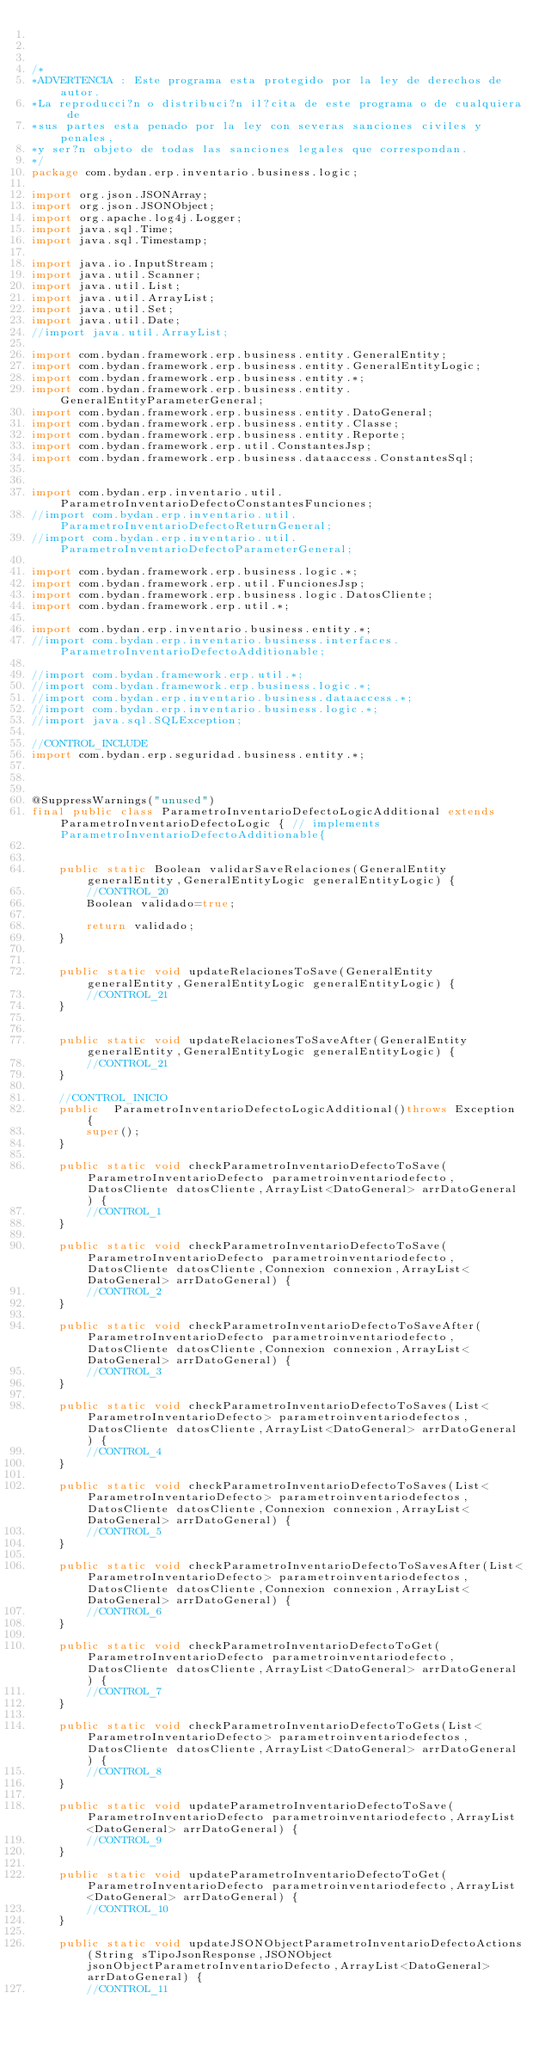<code> <loc_0><loc_0><loc_500><loc_500><_Java_>


/*
*ADVERTENCIA : Este programa esta protegido por la ley de derechos de autor.
*La reproducci?n o distribuci?n il?cita de este programa o de cualquiera de
*sus partes esta penado por la ley con severas sanciones civiles y penales,
*y ser?n objeto de todas las sanciones legales que correspondan.
*/
package com.bydan.erp.inventario.business.logic;

import org.json.JSONArray;
import org.json.JSONObject;
import org.apache.log4j.Logger;
import java.sql.Time;
import java.sql.Timestamp;

import java.io.InputStream;
import java.util.Scanner;
import java.util.List;
import java.util.ArrayList;
import java.util.Set;
import java.util.Date;
//import java.util.ArrayList;

import com.bydan.framework.erp.business.entity.GeneralEntity;
import com.bydan.framework.erp.business.entity.GeneralEntityLogic;
import com.bydan.framework.erp.business.entity.*;
import com.bydan.framework.erp.business.entity.GeneralEntityParameterGeneral;
import com.bydan.framework.erp.business.entity.DatoGeneral;
import com.bydan.framework.erp.business.entity.Classe;
import com.bydan.framework.erp.business.entity.Reporte;
import com.bydan.framework.erp.util.ConstantesJsp;
import com.bydan.framework.erp.business.dataaccess.ConstantesSql;


import com.bydan.erp.inventario.util.ParametroInventarioDefectoConstantesFunciones;
//import com.bydan.erp.inventario.util.ParametroInventarioDefectoReturnGeneral;
//import com.bydan.erp.inventario.util.ParametroInventarioDefectoParameterGeneral;

import com.bydan.framework.erp.business.logic.*;
import com.bydan.framework.erp.util.FuncionesJsp;
import com.bydan.framework.erp.business.logic.DatosCliente;
import com.bydan.framework.erp.util.*;

import com.bydan.erp.inventario.business.entity.*;
//import com.bydan.erp.inventario.business.interfaces.ParametroInventarioDefectoAdditionable;

//import com.bydan.framework.erp.util.*;
//import com.bydan.framework.erp.business.logic.*;
//import com.bydan.erp.inventario.business.dataaccess.*;
//import com.bydan.erp.inventario.business.logic.*;
//import java.sql.SQLException;

//CONTROL_INCLUDE
import com.bydan.erp.seguridad.business.entity.*;



@SuppressWarnings("unused")
final public class ParametroInventarioDefectoLogicAdditional extends ParametroInventarioDefectoLogic { // implements ParametroInventarioDefectoAdditionable{		
	

	public static Boolean validarSaveRelaciones(GeneralEntity generalEntity,GeneralEntityLogic generalEntityLogic) {
		//CONTROL_20
		Boolean validado=true;

		return validado;	
	}


	public static void updateRelacionesToSave(GeneralEntity generalEntity,GeneralEntityLogic generalEntityLogic) {
		//CONTROL_21
	}


	public static void updateRelacionesToSaveAfter(GeneralEntity generalEntity,GeneralEntityLogic generalEntityLogic) {
		//CONTROL_21
	}

	//CONTROL_INICIO
	public  ParametroInventarioDefectoLogicAdditional()throws Exception {
		super();
    }
	
	public static void checkParametroInventarioDefectoToSave(ParametroInventarioDefecto parametroinventariodefecto,DatosCliente datosCliente,ArrayList<DatoGeneral> arrDatoGeneral) {	
		//CONTROL_1
	}
	
	public static void checkParametroInventarioDefectoToSave(ParametroInventarioDefecto parametroinventariodefecto,DatosCliente datosCliente,Connexion connexion,ArrayList<DatoGeneral> arrDatoGeneral) {	
		//CONTROL_2
	}
	
	public static void checkParametroInventarioDefectoToSaveAfter(ParametroInventarioDefecto parametroinventariodefecto,DatosCliente datosCliente,Connexion connexion,ArrayList<DatoGeneral> arrDatoGeneral) {	
		//CONTROL_3
	}
	
	public static void checkParametroInventarioDefectoToSaves(List<ParametroInventarioDefecto> parametroinventariodefectos,DatosCliente datosCliente,ArrayList<DatoGeneral> arrDatoGeneral) {	
		//CONTROL_4
	}
	
	public static void checkParametroInventarioDefectoToSaves(List<ParametroInventarioDefecto> parametroinventariodefectos,DatosCliente datosCliente,Connexion connexion,ArrayList<DatoGeneral> arrDatoGeneral) {	
		//CONTROL_5
	}
	
	public static void checkParametroInventarioDefectoToSavesAfter(List<ParametroInventarioDefecto> parametroinventariodefectos,DatosCliente datosCliente,Connexion connexion,ArrayList<DatoGeneral> arrDatoGeneral) {	
		//CONTROL_6
	}
	
	public static void checkParametroInventarioDefectoToGet(ParametroInventarioDefecto parametroinventariodefecto,DatosCliente datosCliente,ArrayList<DatoGeneral> arrDatoGeneral) {	
		//CONTROL_7
	}
	
	public static void checkParametroInventarioDefectoToGets(List<ParametroInventarioDefecto> parametroinventariodefectos,DatosCliente datosCliente,ArrayList<DatoGeneral> arrDatoGeneral) {	
		//CONTROL_8
	}
	
	public static void updateParametroInventarioDefectoToSave(ParametroInventarioDefecto parametroinventariodefecto,ArrayList<DatoGeneral> arrDatoGeneral) {	
		//CONTROL_9
	}		
						
	public static void updateParametroInventarioDefectoToGet(ParametroInventarioDefecto parametroinventariodefecto,ArrayList<DatoGeneral> arrDatoGeneral) {	
		//CONTROL_10
	}	
	
	public static void updateJSONObjectParametroInventarioDefectoActions(String sTipoJsonResponse,JSONObject jsonObjectParametroInventarioDefecto,ArrayList<DatoGeneral> arrDatoGeneral) {	
		//CONTROL_11</code> 